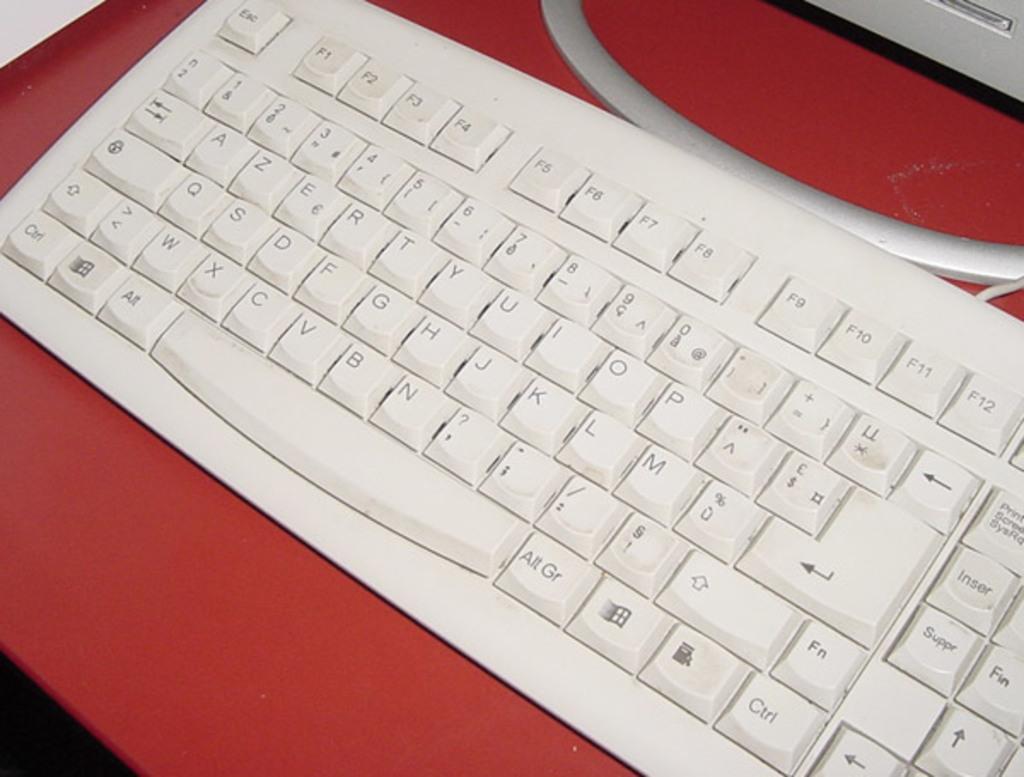What does the button directly below "fn" say?
Ensure brevity in your answer.  Ctrl. Which key is at the bottom left of the keyboard?
Your answer should be compact. Ctrl. 